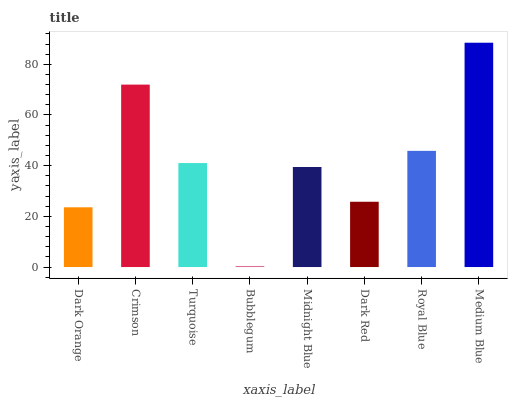Is Bubblegum the minimum?
Answer yes or no. Yes. Is Medium Blue the maximum?
Answer yes or no. Yes. Is Crimson the minimum?
Answer yes or no. No. Is Crimson the maximum?
Answer yes or no. No. Is Crimson greater than Dark Orange?
Answer yes or no. Yes. Is Dark Orange less than Crimson?
Answer yes or no. Yes. Is Dark Orange greater than Crimson?
Answer yes or no. No. Is Crimson less than Dark Orange?
Answer yes or no. No. Is Turquoise the high median?
Answer yes or no. Yes. Is Midnight Blue the low median?
Answer yes or no. Yes. Is Royal Blue the high median?
Answer yes or no. No. Is Dark Orange the low median?
Answer yes or no. No. 